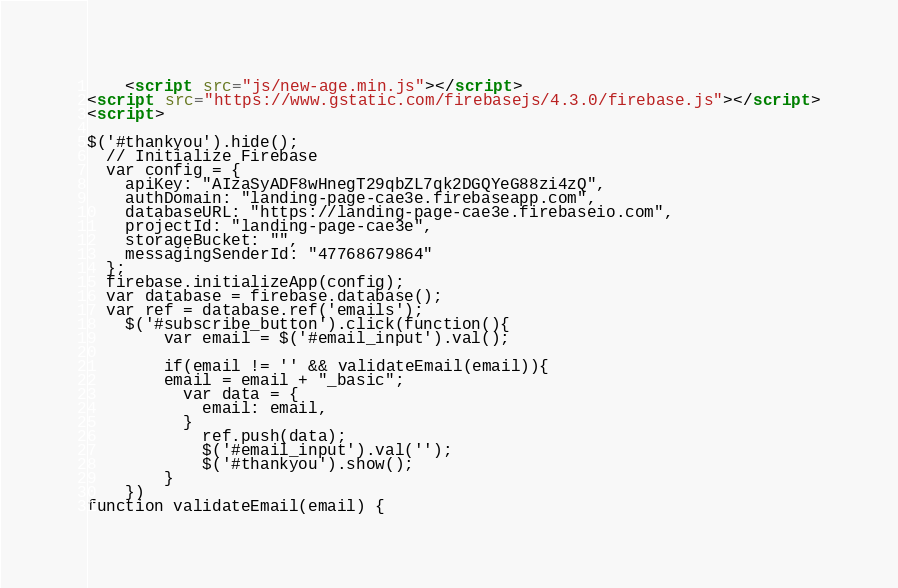Convert code to text. <code><loc_0><loc_0><loc_500><loc_500><_HTML_>    <script src="js/new-age.min.js"></script>
<script src="https://www.gstatic.com/firebasejs/4.3.0/firebase.js"></script>
<script>

$('#thankyou').hide();
  // Initialize Firebase
  var config = {
    apiKey: "AIzaSyADF8wHnegT29qbZL7qk2DGQYeG88zi4zQ",
    authDomain: "landing-page-cae3e.firebaseapp.com",
    databaseURL: "https://landing-page-cae3e.firebaseio.com",
    projectId: "landing-page-cae3e",
    storageBucket: "",
    messagingSenderId: "47768679864"
  };
  firebase.initializeApp(config);
  var database = firebase.database();
  var ref = database.ref('emails');
	$('#subscribe_button').click(function(){
		var email = $('#email_input').val();
		
		if(email != '' && validateEmail(email)){
		email = email + "_basic";
		  var data = {
			email: email,
		  }
			ref.push(data);
			$('#email_input').val('');
			$('#thankyou').show();
		}
	})
function validateEmail(email) {</code> 